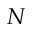Convert formula to latex. <formula><loc_0><loc_0><loc_500><loc_500>N</formula> 